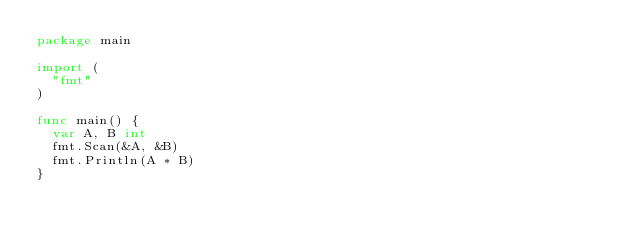<code> <loc_0><loc_0><loc_500><loc_500><_Go_>package main

import (
	"fmt"
)

func main() {
	var A, B int
	fmt.Scan(&A, &B)
	fmt.Println(A * B)
}
</code> 